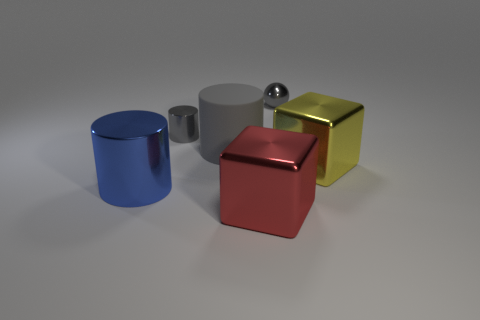Are there any other things that have the same material as the large gray cylinder?
Provide a short and direct response. No. What is the size of the gray metallic object that is to the right of the big red shiny object?
Ensure brevity in your answer.  Small. What is the material of the small gray cylinder?
Provide a short and direct response. Metal. How many things are either tiny shiny objects that are left of the tiny gray shiny sphere or objects left of the large red thing?
Make the answer very short. 3. What number of other things are there of the same color as the small ball?
Your response must be concise. 2. Is the shape of the large blue object the same as the gray shiny thing on the right side of the red thing?
Offer a terse response. No. Are there fewer big blue objects on the right side of the blue object than large cylinders that are in front of the gray rubber cylinder?
Offer a terse response. Yes. What material is the red thing that is the same shape as the yellow shiny thing?
Make the answer very short. Metal. Do the matte cylinder and the large shiny cylinder have the same color?
Your answer should be very brief. No. What is the shape of the big red object that is made of the same material as the tiny gray cylinder?
Provide a short and direct response. Cube. 